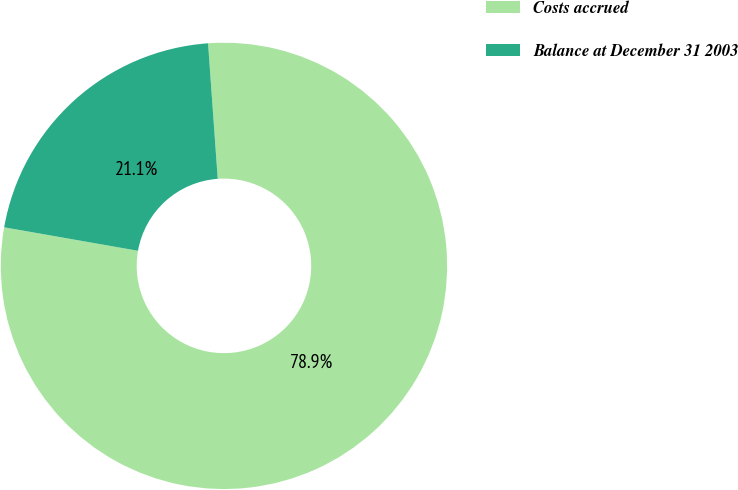Convert chart to OTSL. <chart><loc_0><loc_0><loc_500><loc_500><pie_chart><fcel>Costs accrued<fcel>Balance at December 31 2003<nl><fcel>78.9%<fcel>21.1%<nl></chart> 